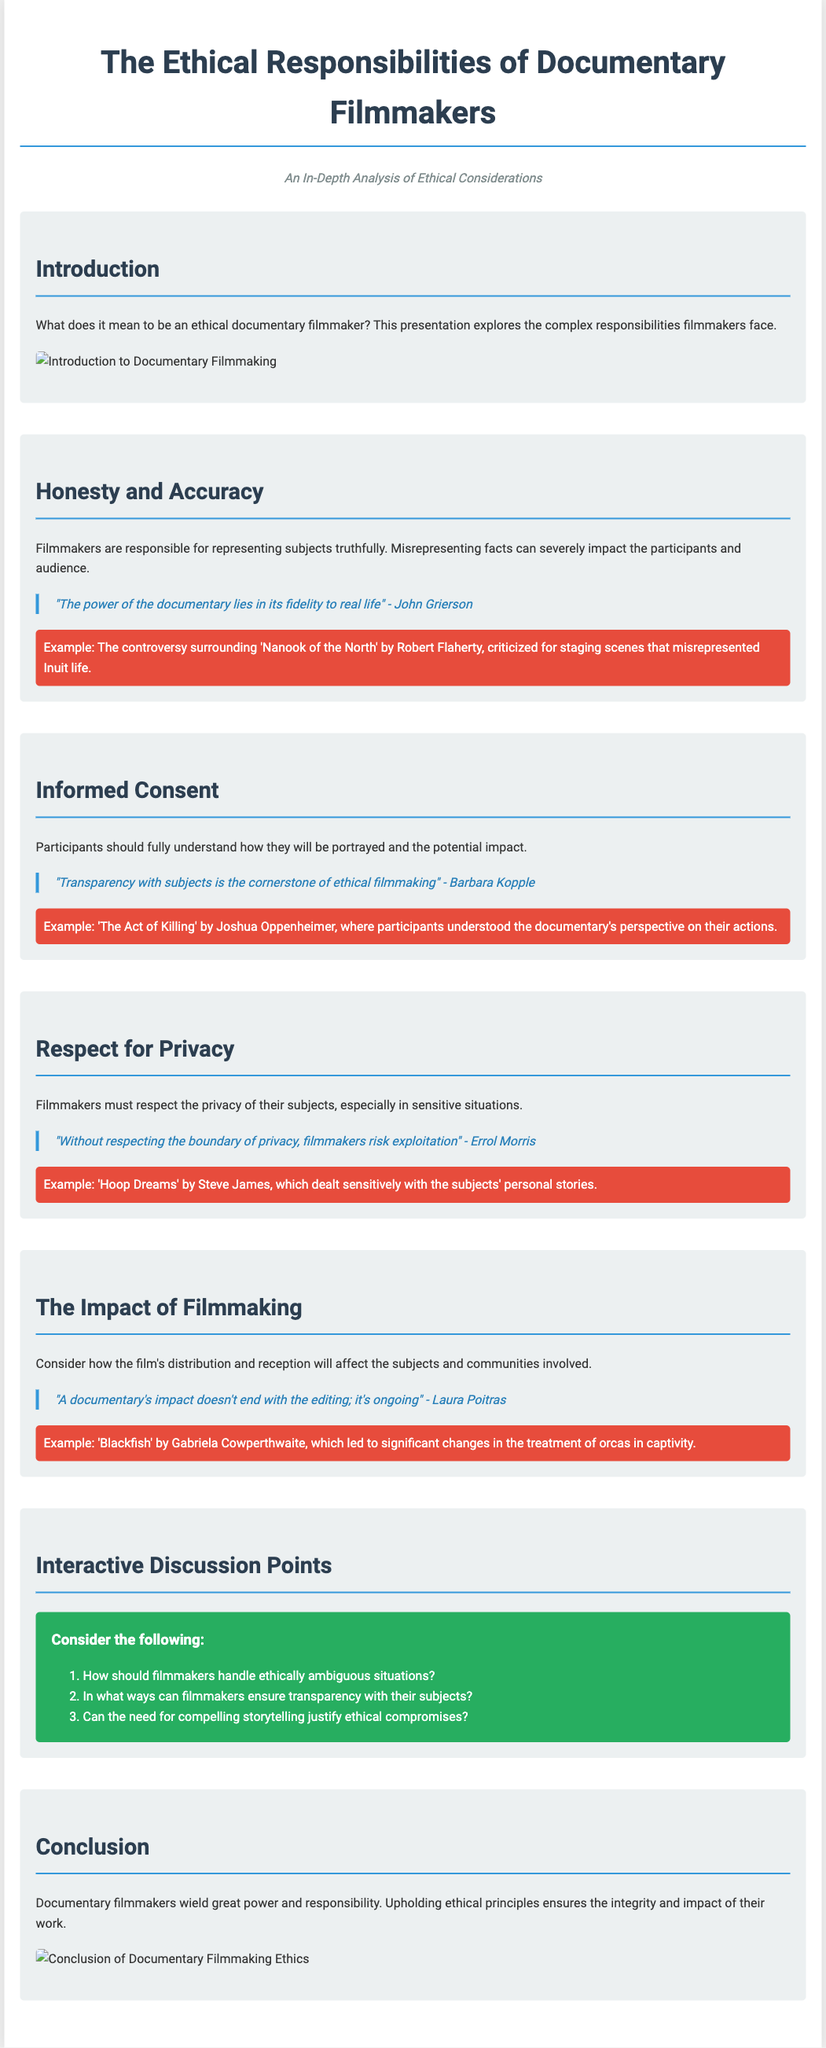What is the title of the presentation? The title is the main heading displayed on the first slide of the presentation.
Answer: The Ethical Responsibilities of Documentary Filmmakers Who quoted "The power of the documentary lies in its fidelity to real life"? This quote is attributed to a renowned filmmaker discussing the essence of documentary filmmaking.
Answer: John Grierson What is emphasized as the cornerstone of ethical filmmaking? This is mentioned in relation to participants understanding and agreeing to their portrayal in the film.
Answer: Transparency with subjects Which documentary is mentioned for its sensitive treatment of personal stories? The documentary is highlighted as an example of respecting the privacy of subjects.
Answer: Hoop Dreams How many interactive discussion points are listed in the presentation? The number of points appears in the "Interactive Discussion Points" slide.
Answer: Three What is the main responsibility of filmmakers according to the presented conclusion? The conclusion highlights the overarching theme regarding the responsibilities of documentary filmmakers.
Answer: Upholding ethical principles What impact does Laura Poitras attribute to documentary filmmaking? The quote reflects the ongoing effect of documentaries on viewers and subjects.
Answer: Ongoing What kind of situations should filmmakers handle according to the discussion points? This question addresses ethical dilemmas, referring to a specific type of circumstance filmmakers may face.
Answer: Ethically ambiguous situations 